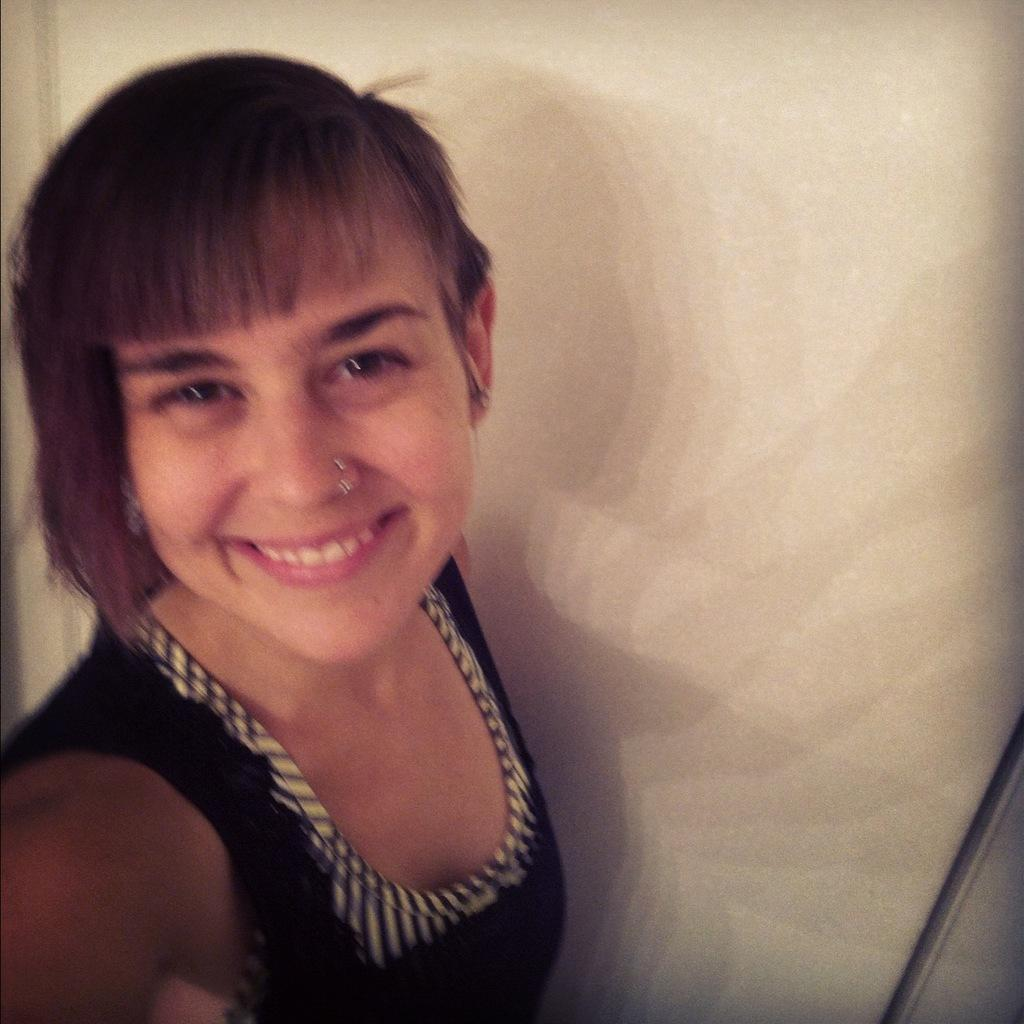Who is present in the image? There is a woman in the picture. Where is the woman located in the image? The woman is on the left side of the image. What expression does the woman have? The woman is smiling. What type of bird is the woman holding in the image? There is no bird present in the image; it features a woman on the left side of the image with a smile. What badge is the woman wearing in the image? There is no badge visible in the image; the woman is simply smiling. 